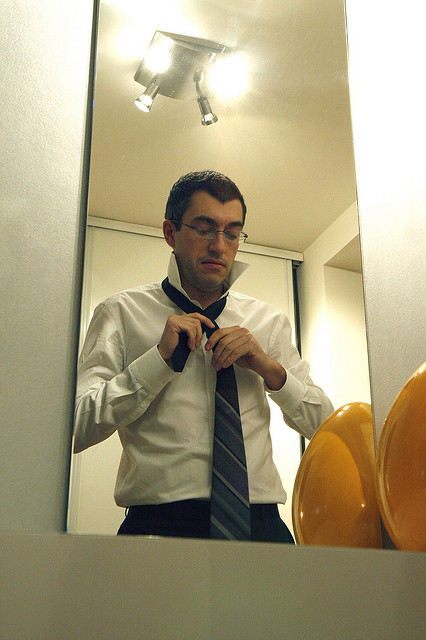What does the image mainly depict? The image primarily depicts a man wearing a white shirt and glasses, adjusting his necktie while standing in front of a mirror. The setting suggests a moment of personal preparation, likely for a formal event or important occasion. 